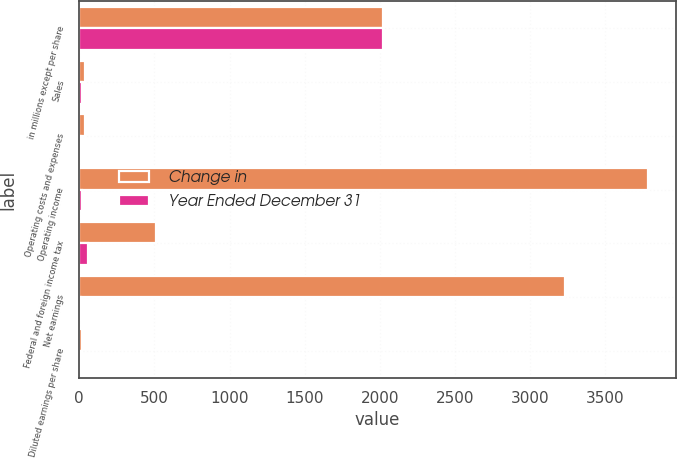Convert chart. <chart><loc_0><loc_0><loc_500><loc_500><stacked_bar_chart><ecel><fcel>in millions except per share<fcel>Sales<fcel>Operating costs and expenses<fcel>Operating income<fcel>Federal and foreign income tax<fcel>Net earnings<fcel>Diluted earnings per share<nl><fcel>Change in<fcel>2018<fcel>40.245<fcel>40.245<fcel>3780<fcel>513<fcel>3229<fcel>18.49<nl><fcel>Year Ended December 31<fcel>2018<fcel>16<fcel>15<fcel>17<fcel>62<fcel>13<fcel>13<nl></chart> 